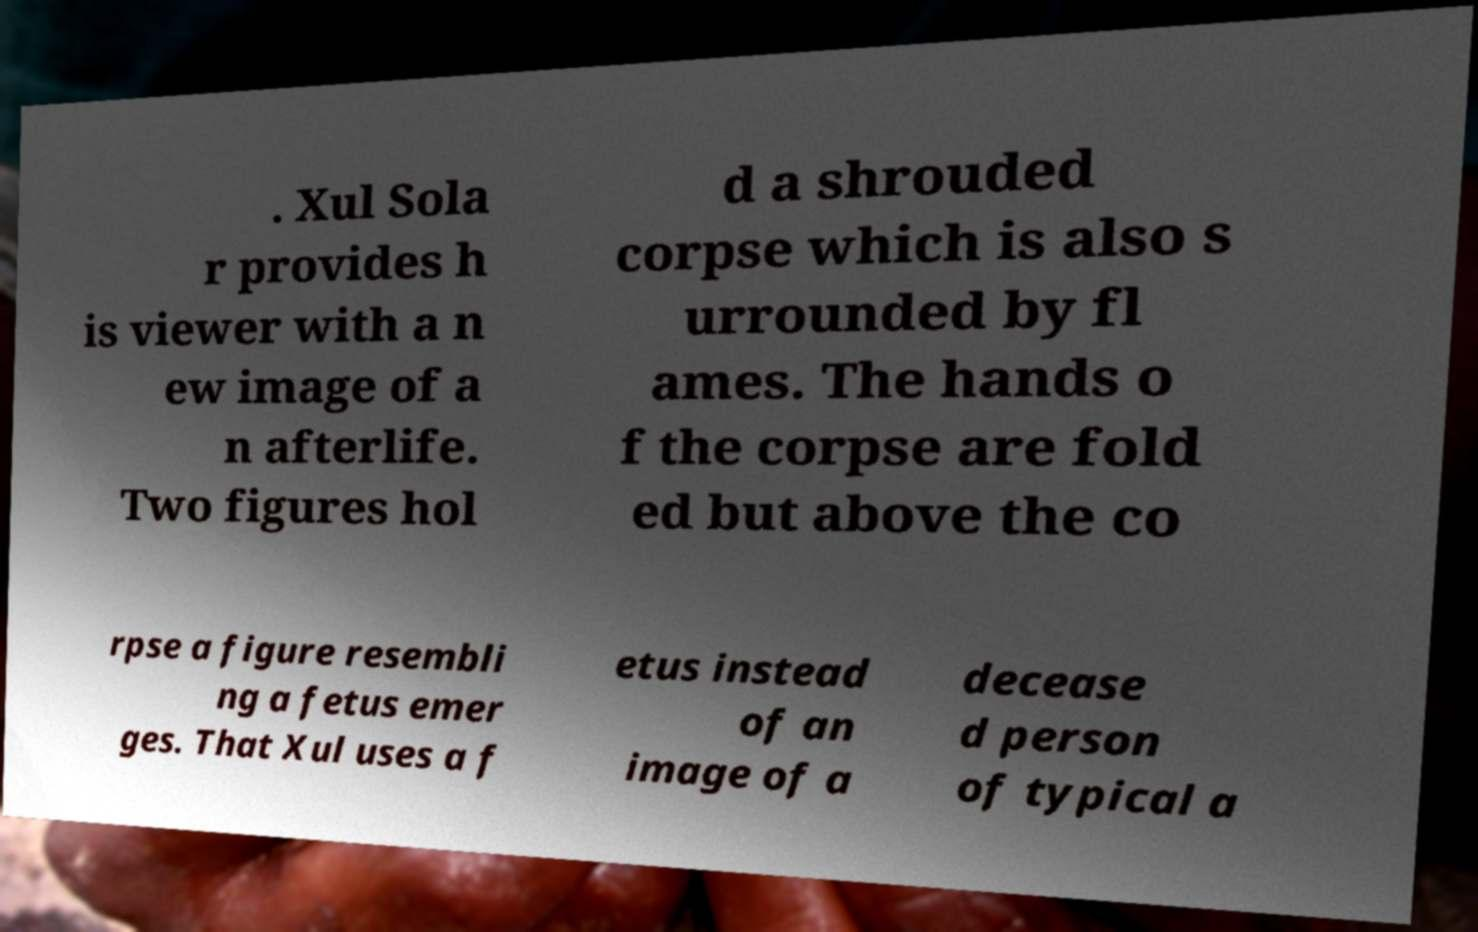Can you accurately transcribe the text from the provided image for me? . Xul Sola r provides h is viewer with a n ew image of a n afterlife. Two figures hol d a shrouded corpse which is also s urrounded by fl ames. The hands o f the corpse are fold ed but above the co rpse a figure resembli ng a fetus emer ges. That Xul uses a f etus instead of an image of a decease d person of typical a 